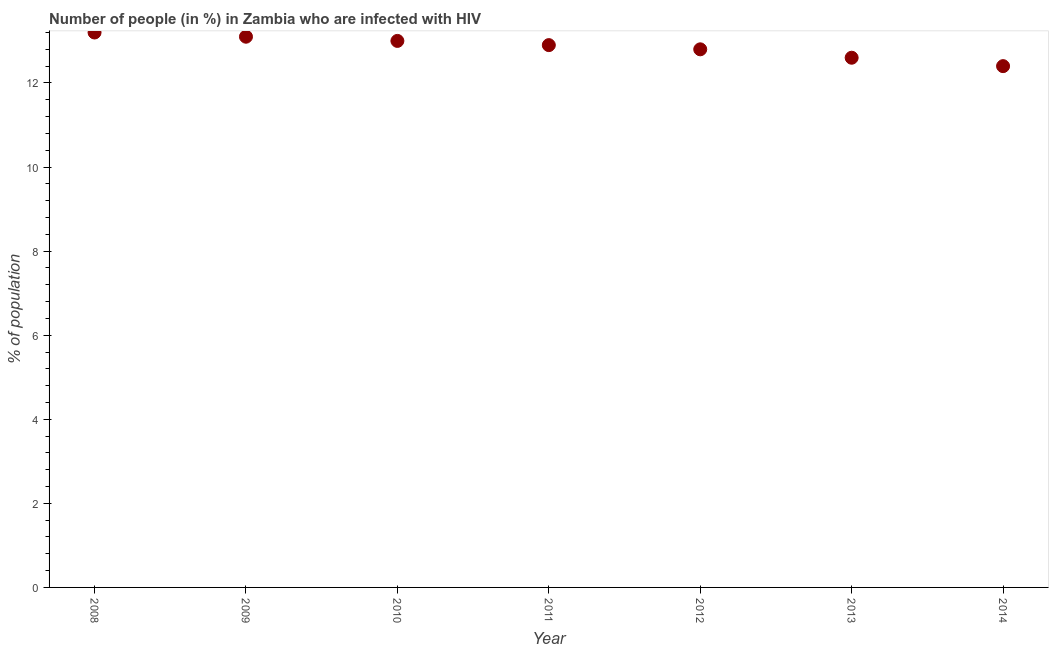What is the number of people infected with hiv in 2012?
Offer a very short reply. 12.8. Across all years, what is the maximum number of people infected with hiv?
Make the answer very short. 13.2. What is the sum of the number of people infected with hiv?
Provide a short and direct response. 90. What is the difference between the number of people infected with hiv in 2008 and 2013?
Keep it short and to the point. 0.6. What is the average number of people infected with hiv per year?
Your answer should be compact. 12.86. Do a majority of the years between 2013 and 2008 (inclusive) have number of people infected with hiv greater than 6.4 %?
Provide a short and direct response. Yes. What is the ratio of the number of people infected with hiv in 2009 to that in 2013?
Offer a very short reply. 1.04. What is the difference between the highest and the second highest number of people infected with hiv?
Give a very brief answer. 0.1. What is the difference between the highest and the lowest number of people infected with hiv?
Provide a succinct answer. 0.8. How many dotlines are there?
Offer a very short reply. 1. What is the difference between two consecutive major ticks on the Y-axis?
Provide a short and direct response. 2. Does the graph contain any zero values?
Your answer should be very brief. No. Does the graph contain grids?
Provide a short and direct response. No. What is the title of the graph?
Your answer should be compact. Number of people (in %) in Zambia who are infected with HIV. What is the label or title of the X-axis?
Provide a short and direct response. Year. What is the label or title of the Y-axis?
Keep it short and to the point. % of population. What is the % of population in 2011?
Your answer should be compact. 12.9. What is the % of population in 2012?
Your answer should be compact. 12.8. What is the % of population in 2013?
Your response must be concise. 12.6. What is the difference between the % of population in 2008 and 2009?
Your answer should be compact. 0.1. What is the difference between the % of population in 2008 and 2010?
Ensure brevity in your answer.  0.2. What is the difference between the % of population in 2008 and 2011?
Ensure brevity in your answer.  0.3. What is the difference between the % of population in 2008 and 2012?
Keep it short and to the point. 0.4. What is the difference between the % of population in 2008 and 2013?
Offer a very short reply. 0.6. What is the difference between the % of population in 2009 and 2011?
Your answer should be very brief. 0.2. What is the difference between the % of population in 2009 and 2012?
Keep it short and to the point. 0.3. What is the difference between the % of population in 2009 and 2013?
Make the answer very short. 0.5. What is the difference between the % of population in 2010 and 2011?
Provide a short and direct response. 0.1. What is the difference between the % of population in 2013 and 2014?
Give a very brief answer. 0.2. What is the ratio of the % of population in 2008 to that in 2009?
Offer a terse response. 1.01. What is the ratio of the % of population in 2008 to that in 2010?
Make the answer very short. 1.01. What is the ratio of the % of population in 2008 to that in 2012?
Offer a terse response. 1.03. What is the ratio of the % of population in 2008 to that in 2013?
Keep it short and to the point. 1.05. What is the ratio of the % of population in 2008 to that in 2014?
Your answer should be very brief. 1.06. What is the ratio of the % of population in 2009 to that in 2011?
Provide a succinct answer. 1.02. What is the ratio of the % of population in 2009 to that in 2012?
Make the answer very short. 1.02. What is the ratio of the % of population in 2009 to that in 2013?
Offer a very short reply. 1.04. What is the ratio of the % of population in 2009 to that in 2014?
Your response must be concise. 1.06. What is the ratio of the % of population in 2010 to that in 2011?
Ensure brevity in your answer.  1.01. What is the ratio of the % of population in 2010 to that in 2013?
Make the answer very short. 1.03. What is the ratio of the % of population in 2010 to that in 2014?
Your response must be concise. 1.05. What is the ratio of the % of population in 2011 to that in 2012?
Provide a short and direct response. 1.01. What is the ratio of the % of population in 2012 to that in 2014?
Offer a terse response. 1.03. What is the ratio of the % of population in 2013 to that in 2014?
Your answer should be very brief. 1.02. 